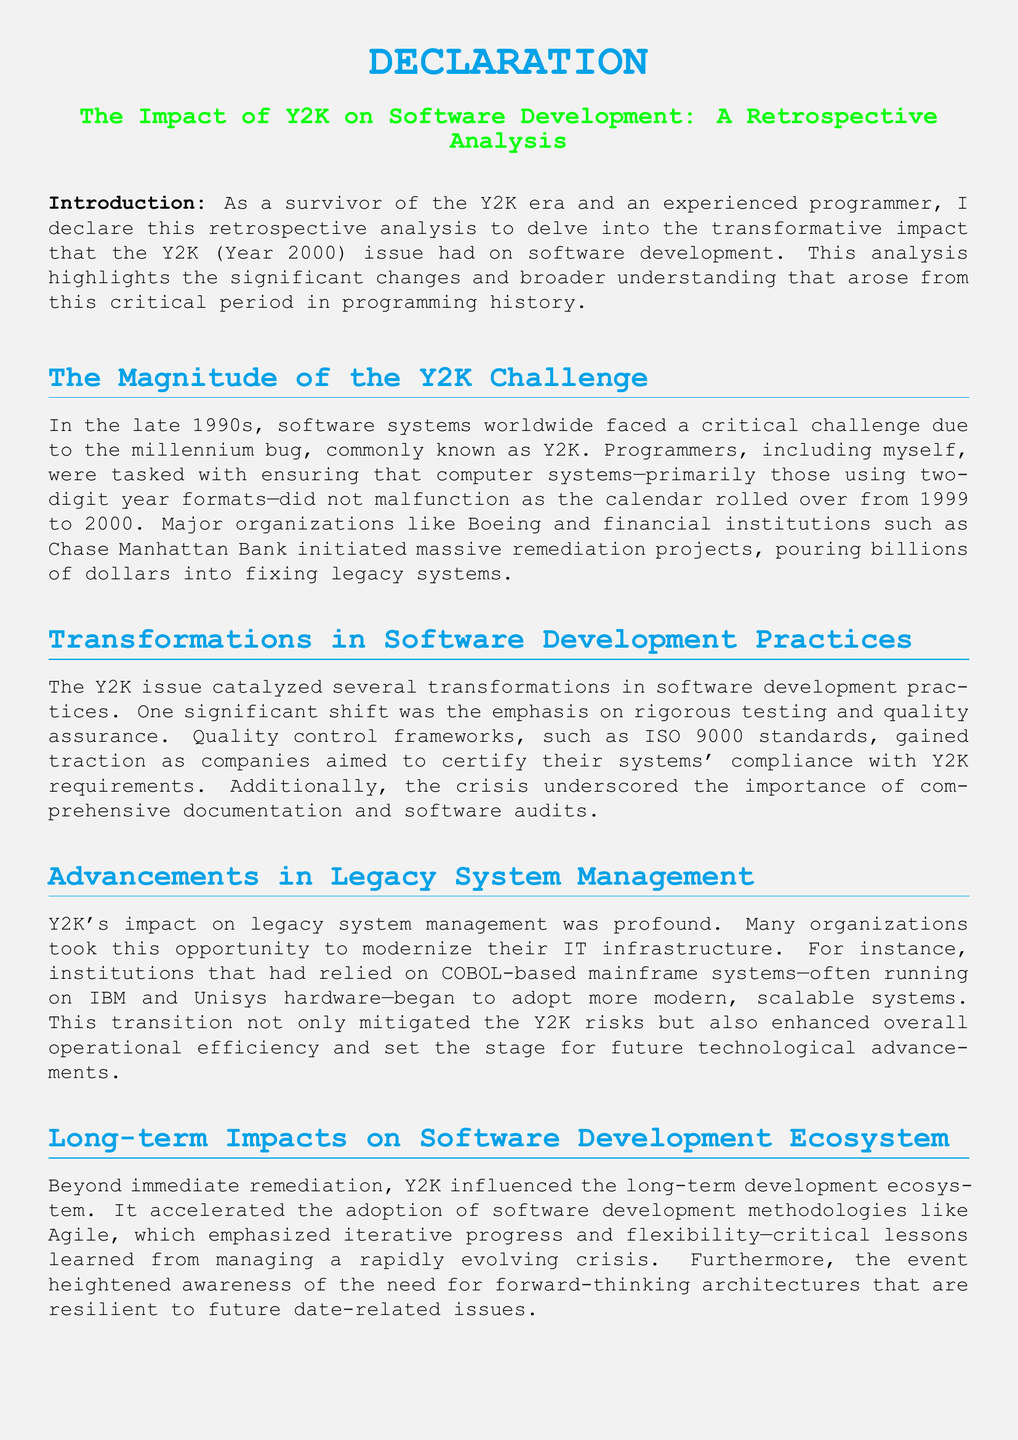What is the title of the document? The title is prominently displayed at the beginning of the document, highlighting its focus.
Answer: The Impact of Y2K on Software Development: A Retrospective Analysis Who initiated massive remediation projects due to Y2K? Various major organizations are mentioned as taking action to address Y2K challenges.
Answer: Boeing and Chase Manhattan Bank What programming language was commonly referenced in the document regarding legacy systems? The document specifically mentions the programming language used in many older systems prior to modernization.
Answer: COBOL What quality control framework gained traction during the Y2K crisis? The document notes the adoption of specific standards aimed at improving software quality.
Answer: ISO 9000 What methodology accelerated due to the lessons learned from Y2K? The text indicates a shift towards a certain methodology in software development as a result of the crisis.
Answer: Agile What was the outcome of the Y2K crisis on operational efficiency? The document states a notable benefit realized by organizations as a result of addressing Y2K issues.
Answer: Enhanced overall operational efficiency Who is the author of the declaration? The author identifies themselves with a specific title that reflects their experiences during the Y2K period.
Answer: Reminiscent Y2K survivor and experienced programmer What does the author affirm in the conclusion? The author concludes the document by stating their stance on the contents discussed throughout the text.
Answer: The contents of this retrospective analysis on the impact of Y2K on software development 